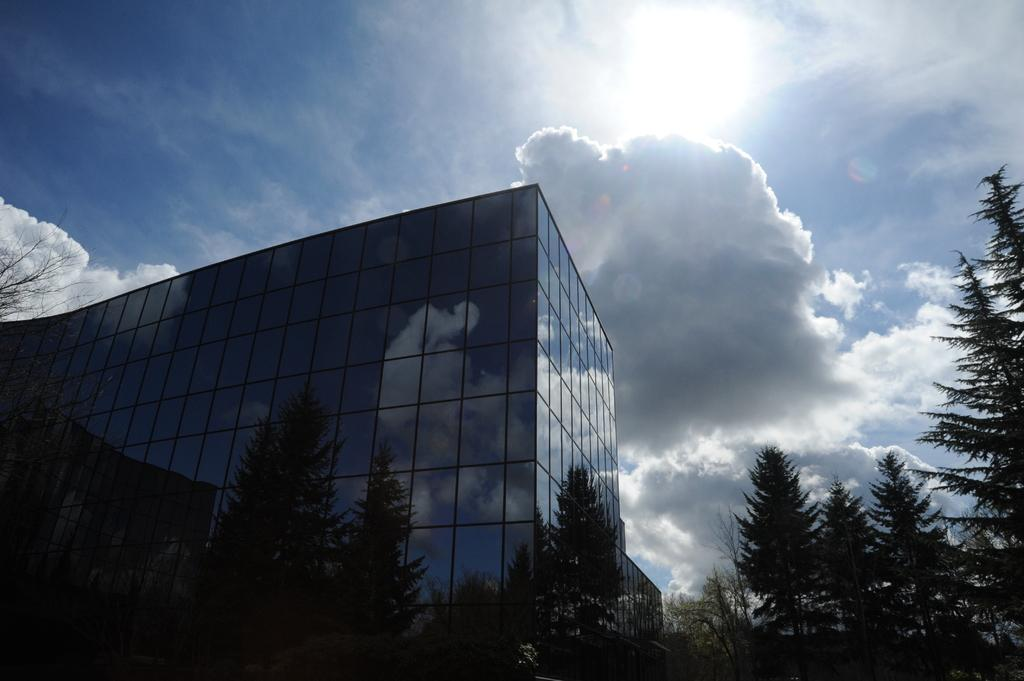What type of natural elements can be seen in the image? There are trees in the image. What type of man-made structures are present in the image? There are buildings in the image. What is visible at the top of the image? The sky is visible at the top of the image. What type of toothbrush is hanging from the tree in the image? There is no toothbrush present in the image; it features trees and buildings. What book is lying on the roof of the building in the image? There is no book present in the image; it features trees, buildings, and the sky. 